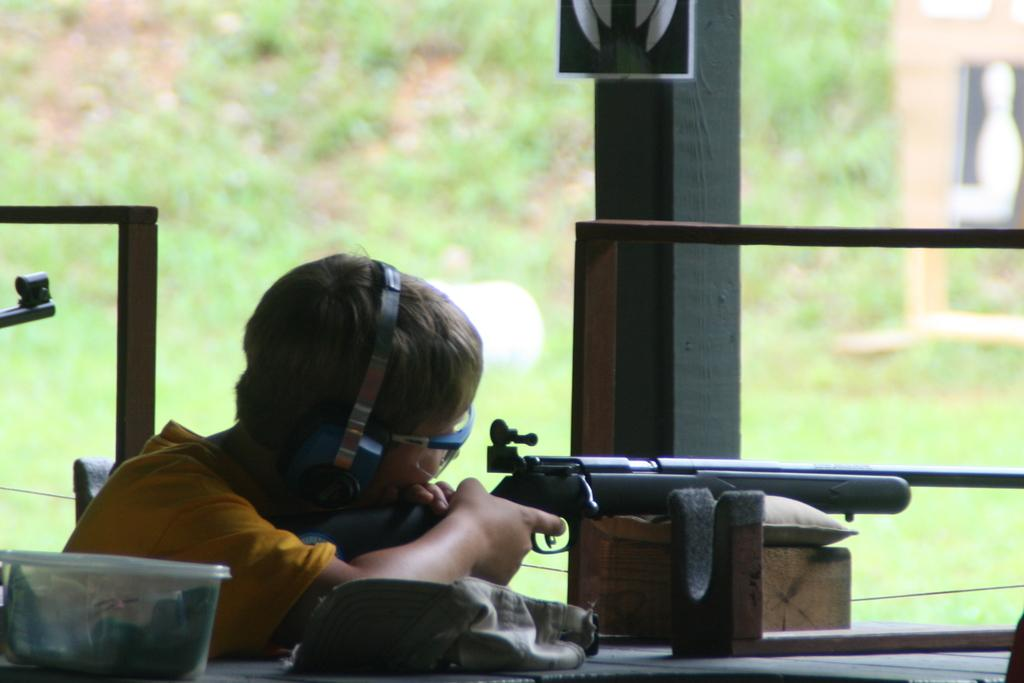What is the main subject of the image? There is a person in the image. What is the person wearing in the image? The person is wearing goggles in the image. What objects can be seen in the image besides the person? There is a rock, a box, a gun, and rods in the image. Can you describe any unspecified objects in the image? There are some unspecified objects in the image. What can be seen in the background of the image? Plants are visible in the background of the image. How would you describe the background of the image? The background is blurry. What type of plane is the person flying in the image? There is no plane present in the image. What is the person cooking in the image? There is no cooking activity depicted in the image. How does the person's digestion appear in the image? There is no indication of the person's digestion in the image. 